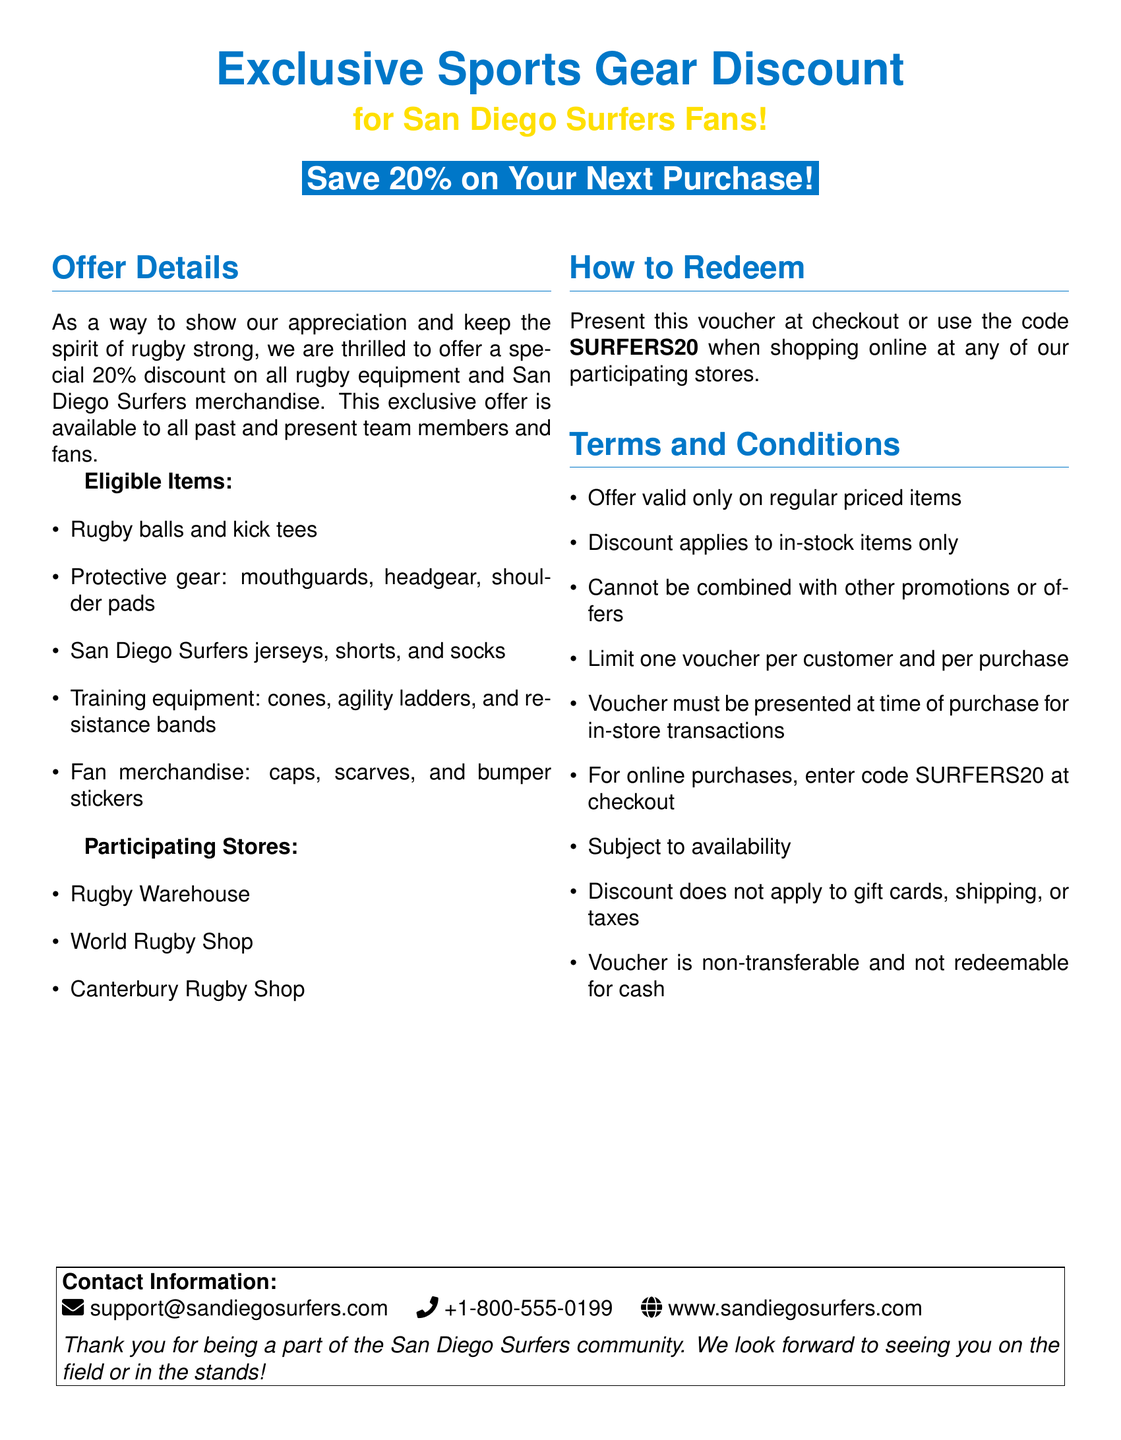What is the discount offered? The document states a special discount of 20% on purchases.
Answer: 20% Who is eligible for the discount? The eligibility for the discount includes all past and present team members and fans.
Answer: Past and present team members and fans What is the redemption code for online shopping? The document specifies that the code SURFERS20 is to be used when shopping online.
Answer: SURFERS20 What items are eligible for the discount? The document lists rugby balls, protective gear, San Diego Surfers merchandise, training equipment, and fan merchandise as eligible items.
Answer: Rugby equipment and San Diego Surfers merchandise How many vouchers can a customer use per purchase? The document states that the limit is one voucher per customer and per purchase.
Answer: One voucher Which store is not mentioned as participating? The document lists specific stores, but there is no mention of other stores that aren't included.
Answer: N/A What type of items does the discount not apply to? It specifically mentions that the discount does not apply to gift cards, shipping, or taxes.
Answer: Gift cards, shipping, or taxes What is the contact email provided in the document? The document lists the email support@sandiegosurfers.com for contact.
Answer: support@sandiegosurfers.com Is the voucher transferable? The document states that the voucher is non-transferable.
Answer: Non-transferable 